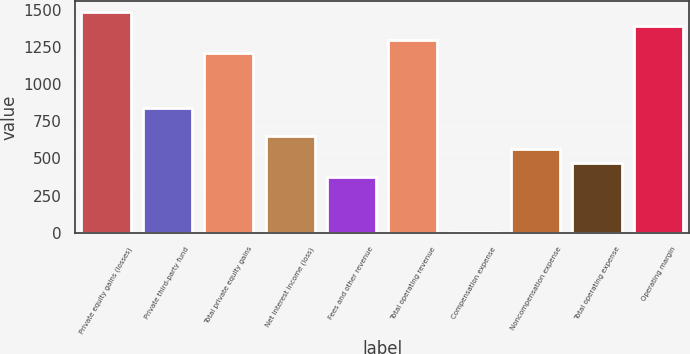Convert chart. <chart><loc_0><loc_0><loc_500><loc_500><bar_chart><fcel>Private equity gains (losses)<fcel>Private third-party fund<fcel>Total private equity gains<fcel>Net interest income (loss)<fcel>Fees and other revenue<fcel>Total operating revenue<fcel>Compensation expense<fcel>Noncompensation expense<fcel>Total operating expense<fcel>Operating margin<nl><fcel>1482.2<fcel>836.8<fcel>1205.6<fcel>652.4<fcel>375.8<fcel>1297.8<fcel>7<fcel>560.2<fcel>468<fcel>1390<nl></chart> 